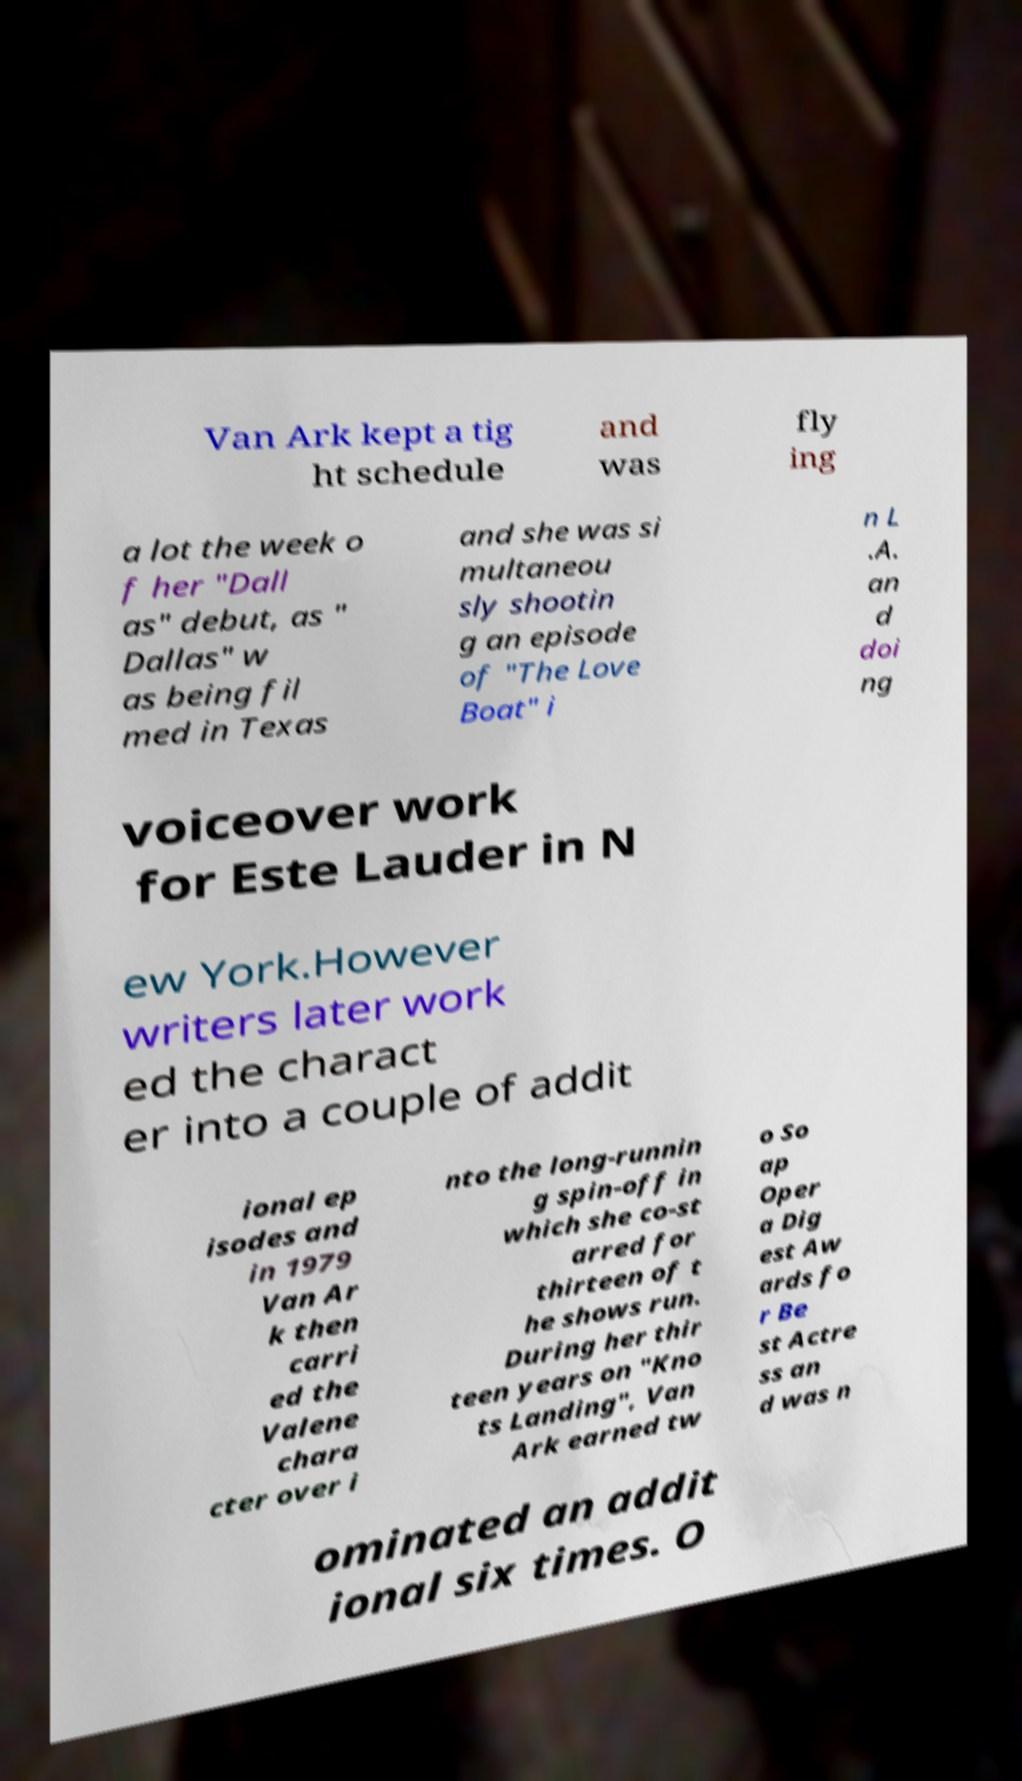There's text embedded in this image that I need extracted. Can you transcribe it verbatim? Van Ark kept a tig ht schedule and was fly ing a lot the week o f her "Dall as" debut, as " Dallas" w as being fil med in Texas and she was si multaneou sly shootin g an episode of "The Love Boat" i n L .A. an d doi ng voiceover work for Este Lauder in N ew York.However writers later work ed the charact er into a couple of addit ional ep isodes and in 1979 Van Ar k then carri ed the Valene chara cter over i nto the long-runnin g spin-off in which she co-st arred for thirteen of t he shows run. During her thir teen years on "Kno ts Landing", Van Ark earned tw o So ap Oper a Dig est Aw ards fo r Be st Actre ss an d was n ominated an addit ional six times. O 